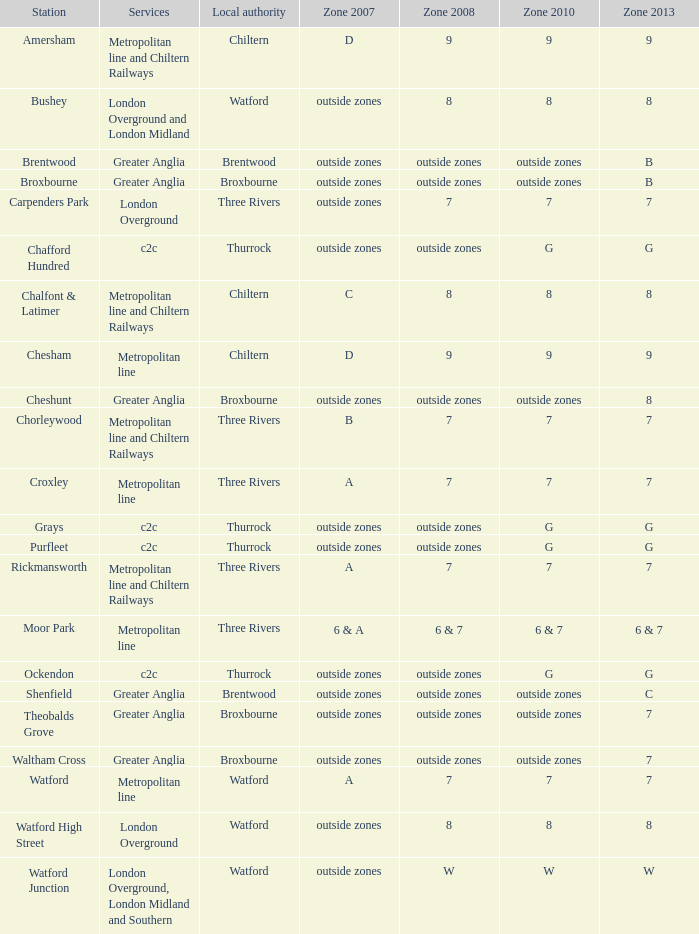Which Station has a Zone 2010 of 7? Carpenders Park, Chorleywood, Croxley, Rickmansworth, Watford. 